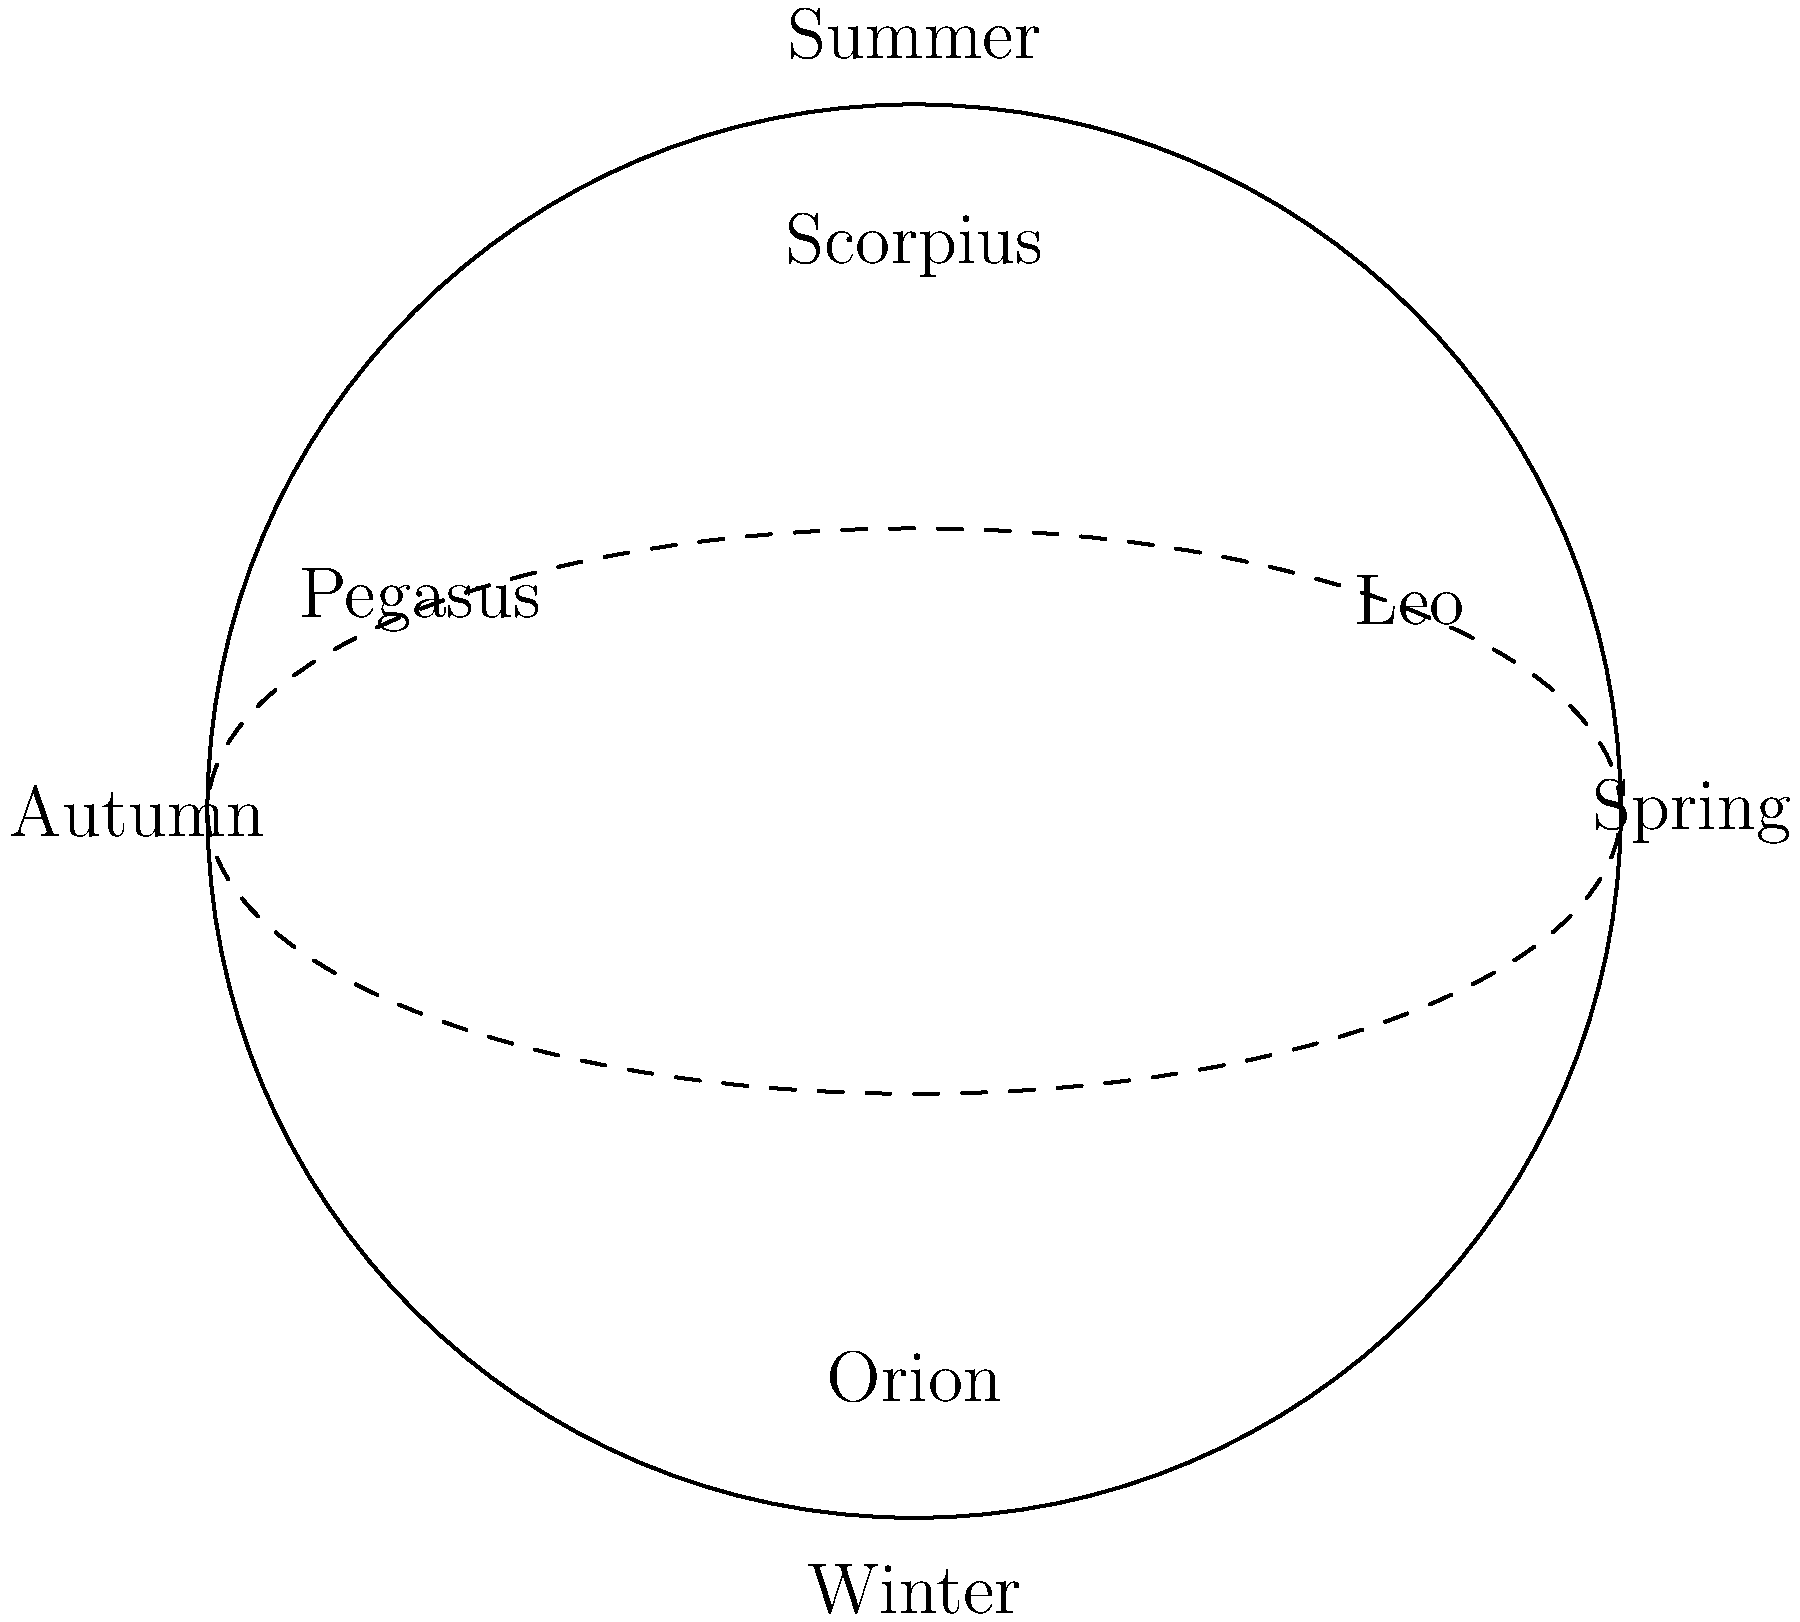As a company representative sponsoring an astronomy podcast, you're attending a recording session where the host is discussing seasonal constellations. Which constellation mentioned in the diagram would be most prominent during your company's winter marketing campaign? To determine the most prominent constellation during a winter marketing campaign, we need to follow these steps:

1. Understand the diagram:
   - The circle represents the celestial sphere as seen from Earth.
   - The dashed line represents the ecliptic (Sun's apparent path).
   - The diagram is divided into four seasons.

2. Locate the winter section:
   - Winter is marked at the bottom of the diagram.

3. Identify the constellation near the winter label:
   - Orion is clearly visible near the winter label.

4. Consider visibility:
   - Constellations near the season labels are typically most visible during that season.
   - Orion is positioned directly in the winter section, making it the most prominent winter constellation among those shown.

5. Marketing relevance:
   - As a company representative, you'd want to align your marketing campaign with the most visible and recognizable winter constellation.
   - Orion, being one of the most well-known constellations, would be an excellent choice for a winter-themed campaign.

Therefore, Orion would be the most prominent constellation during your company's winter marketing campaign.
Answer: Orion 